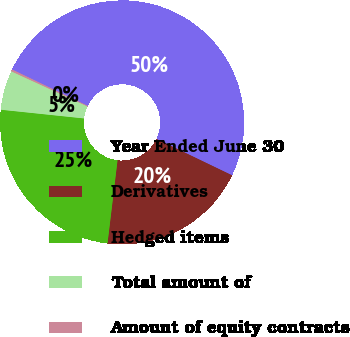<chart> <loc_0><loc_0><loc_500><loc_500><pie_chart><fcel>Year Ended June 30<fcel>Derivatives<fcel>Hedged items<fcel>Total amount of<fcel>Amount of equity contracts<nl><fcel>50.01%<fcel>19.77%<fcel>24.75%<fcel>5.22%<fcel>0.25%<nl></chart> 